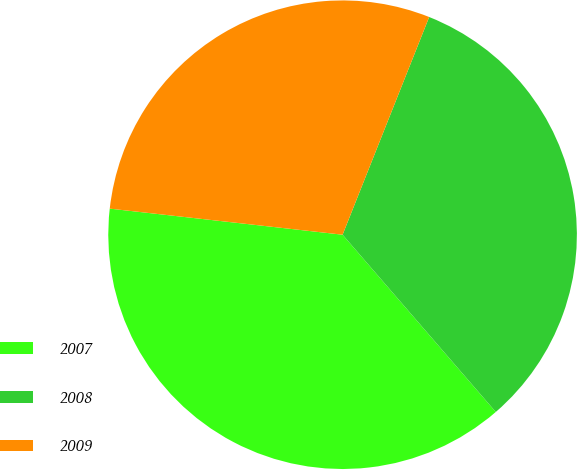Convert chart. <chart><loc_0><loc_0><loc_500><loc_500><pie_chart><fcel>2007<fcel>2008<fcel>2009<nl><fcel>38.12%<fcel>32.63%<fcel>29.25%<nl></chart> 